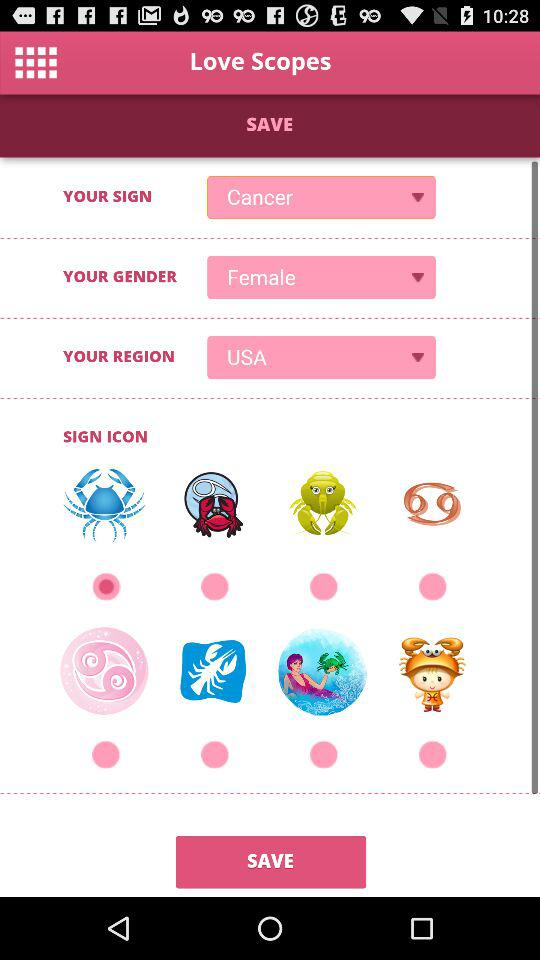What is your gender? Your gender is female. 